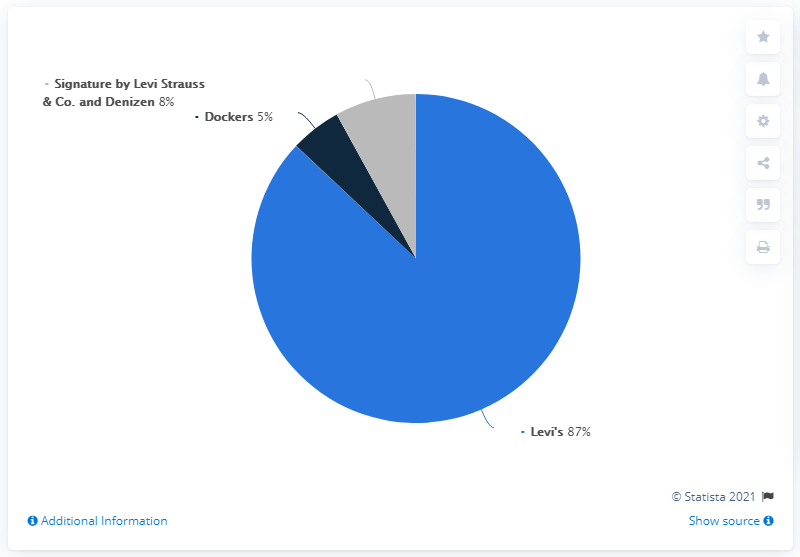Highlight a few significant elements in this photo. In 2020, Levi Strauss' total net sales were 87% Levi brand products. The percentage of Levi's in the pie chart is 87%. The total percentage of expenses other than Levi's is 13%. 